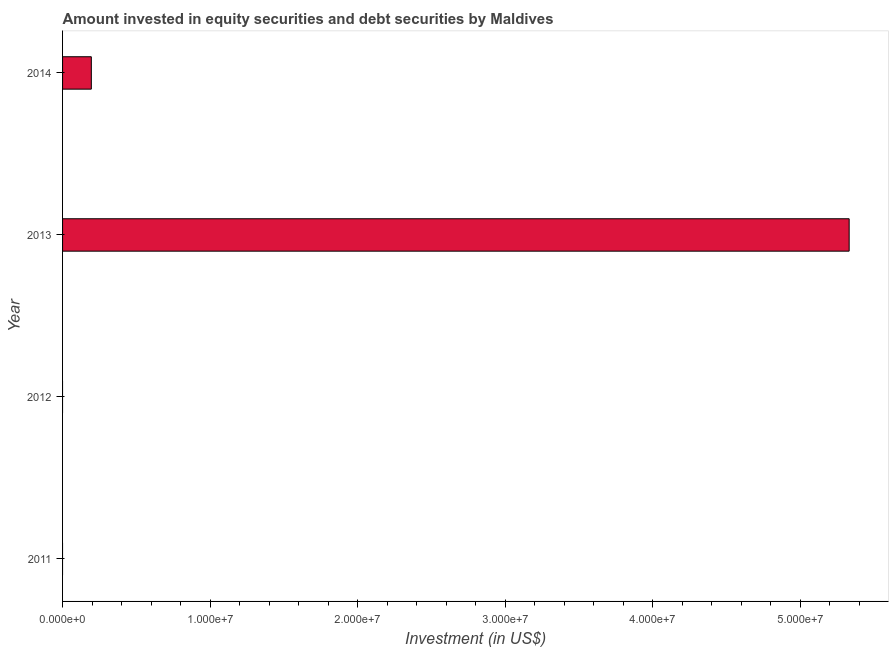What is the title of the graph?
Keep it short and to the point. Amount invested in equity securities and debt securities by Maldives. What is the label or title of the X-axis?
Give a very brief answer. Investment (in US$). What is the portfolio investment in 2014?
Make the answer very short. 1.95e+06. Across all years, what is the maximum portfolio investment?
Give a very brief answer. 5.33e+07. What is the sum of the portfolio investment?
Ensure brevity in your answer.  5.53e+07. What is the difference between the portfolio investment in 2013 and 2014?
Ensure brevity in your answer.  5.14e+07. What is the average portfolio investment per year?
Keep it short and to the point. 1.38e+07. What is the median portfolio investment?
Make the answer very short. 9.75e+05. What is the ratio of the portfolio investment in 2013 to that in 2014?
Ensure brevity in your answer.  27.34. What is the difference between the highest and the lowest portfolio investment?
Your answer should be compact. 5.33e+07. What is the difference between two consecutive major ticks on the X-axis?
Make the answer very short. 1.00e+07. What is the Investment (in US$) of 2011?
Give a very brief answer. 0. What is the Investment (in US$) in 2013?
Offer a very short reply. 5.33e+07. What is the Investment (in US$) of 2014?
Give a very brief answer. 1.95e+06. What is the difference between the Investment (in US$) in 2013 and 2014?
Keep it short and to the point. 5.14e+07. What is the ratio of the Investment (in US$) in 2013 to that in 2014?
Give a very brief answer. 27.34. 